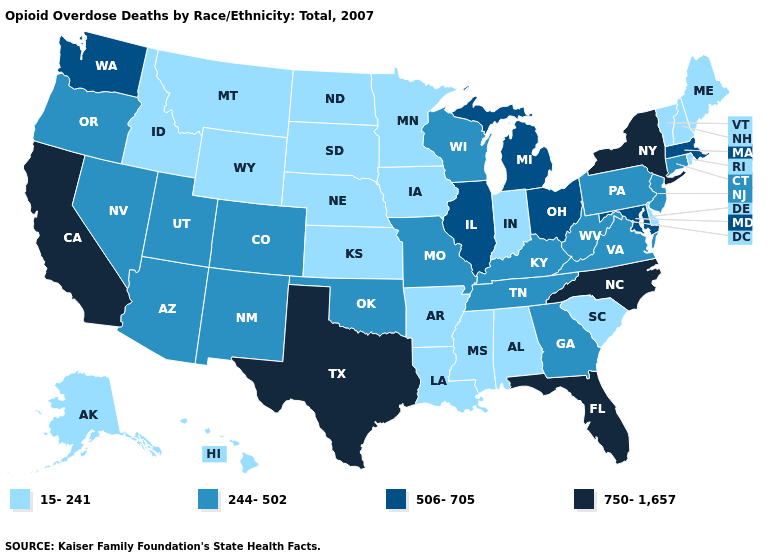What is the value of Rhode Island?
Short answer required. 15-241. Does Washington have the same value as Colorado?
Keep it brief. No. Does California have a lower value than Mississippi?
Short answer required. No. Name the states that have a value in the range 750-1,657?
Answer briefly. California, Florida, New York, North Carolina, Texas. What is the highest value in states that border Georgia?
Quick response, please. 750-1,657. Name the states that have a value in the range 15-241?
Answer briefly. Alabama, Alaska, Arkansas, Delaware, Hawaii, Idaho, Indiana, Iowa, Kansas, Louisiana, Maine, Minnesota, Mississippi, Montana, Nebraska, New Hampshire, North Dakota, Rhode Island, South Carolina, South Dakota, Vermont, Wyoming. Which states hav the highest value in the MidWest?
Give a very brief answer. Illinois, Michigan, Ohio. What is the value of Arizona?
Quick response, please. 244-502. Does New York have the highest value in the Northeast?
Write a very short answer. Yes. Does Rhode Island have the same value as Idaho?
Concise answer only. Yes. Is the legend a continuous bar?
Write a very short answer. No. What is the value of Wyoming?
Short answer required. 15-241. Name the states that have a value in the range 750-1,657?
Answer briefly. California, Florida, New York, North Carolina, Texas. Does Florida have the lowest value in the South?
Answer briefly. No. What is the highest value in the USA?
Quick response, please. 750-1,657. 